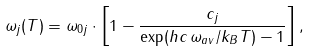<formula> <loc_0><loc_0><loc_500><loc_500>\omega _ { j } ( T ) = \omega _ { 0 j } \cdot \left [ 1 - \frac { c _ { j } } { \exp ( h c \, \omega _ { a v } / k _ { B } T ) - 1 } \right ] ,</formula> 